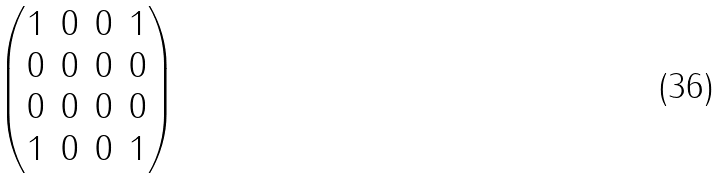Convert formula to latex. <formula><loc_0><loc_0><loc_500><loc_500>\begin{pmatrix} 1 & 0 & 0 & 1 \\ 0 & 0 & 0 & 0 \\ 0 & 0 & 0 & 0 \\ 1 & 0 & 0 & 1 \end{pmatrix}</formula> 